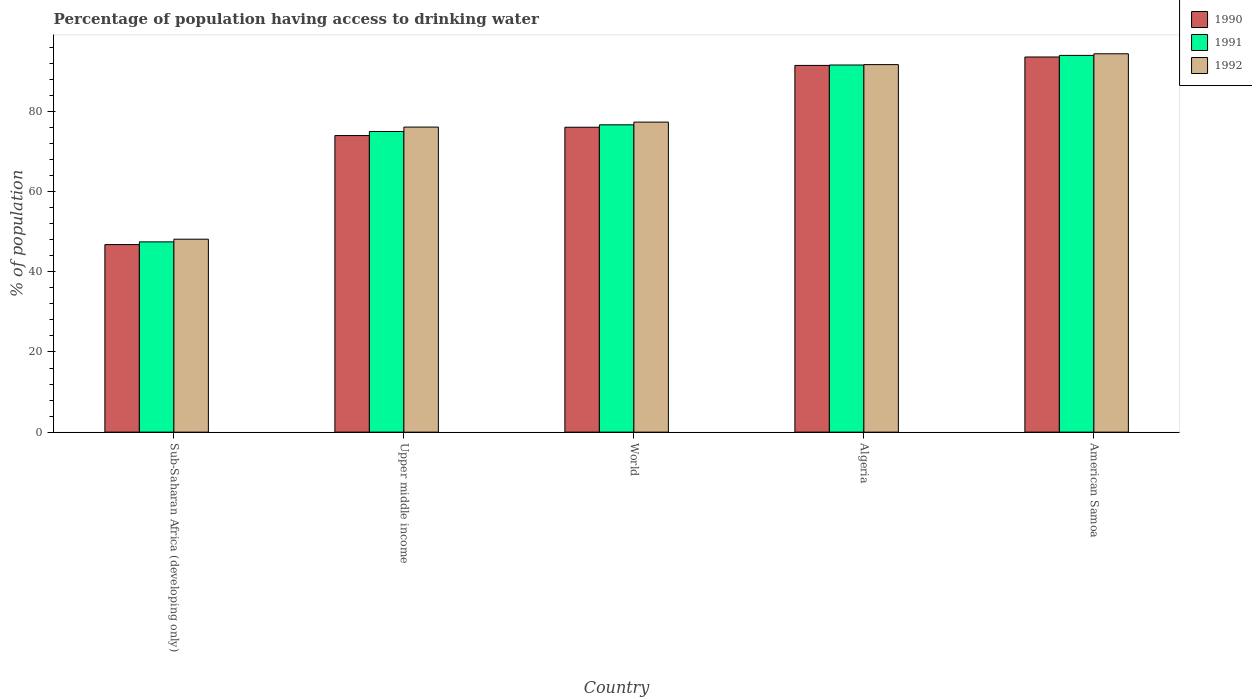Are the number of bars per tick equal to the number of legend labels?
Offer a very short reply. Yes. Are the number of bars on each tick of the X-axis equal?
Give a very brief answer. Yes. What is the label of the 5th group of bars from the left?
Your response must be concise. American Samoa. What is the percentage of population having access to drinking water in 1991 in Algeria?
Offer a terse response. 91.6. Across all countries, what is the maximum percentage of population having access to drinking water in 1991?
Give a very brief answer. 94. Across all countries, what is the minimum percentage of population having access to drinking water in 1990?
Offer a terse response. 46.8. In which country was the percentage of population having access to drinking water in 1990 maximum?
Your answer should be compact. American Samoa. In which country was the percentage of population having access to drinking water in 1991 minimum?
Give a very brief answer. Sub-Saharan Africa (developing only). What is the total percentage of population having access to drinking water in 1991 in the graph?
Your response must be concise. 384.78. What is the difference between the percentage of population having access to drinking water in 1990 in Algeria and that in Upper middle income?
Provide a succinct answer. 17.5. What is the difference between the percentage of population having access to drinking water in 1990 in World and the percentage of population having access to drinking water in 1992 in Upper middle income?
Your answer should be very brief. -0.04. What is the average percentage of population having access to drinking water in 1991 per country?
Your response must be concise. 76.96. What is the difference between the percentage of population having access to drinking water of/in 1991 and percentage of population having access to drinking water of/in 1992 in Upper middle income?
Your answer should be compact. -1.09. In how many countries, is the percentage of population having access to drinking water in 1992 greater than 8 %?
Provide a succinct answer. 5. What is the ratio of the percentage of population having access to drinking water in 1991 in Sub-Saharan Africa (developing only) to that in Upper middle income?
Provide a short and direct response. 0.63. Is the percentage of population having access to drinking water in 1992 in Upper middle income less than that in World?
Your answer should be compact. Yes. What is the difference between the highest and the second highest percentage of population having access to drinking water in 1992?
Keep it short and to the point. 14.35. What is the difference between the highest and the lowest percentage of population having access to drinking water in 1992?
Keep it short and to the point. 46.26. How many bars are there?
Give a very brief answer. 15. Are all the bars in the graph horizontal?
Provide a succinct answer. No. How many countries are there in the graph?
Ensure brevity in your answer.  5. Where does the legend appear in the graph?
Provide a short and direct response. Top right. How many legend labels are there?
Provide a succinct answer. 3. What is the title of the graph?
Your response must be concise. Percentage of population having access to drinking water. What is the label or title of the Y-axis?
Offer a very short reply. % of population. What is the % of population in 1990 in Sub-Saharan Africa (developing only)?
Your response must be concise. 46.8. What is the % of population of 1991 in Sub-Saharan Africa (developing only)?
Your response must be concise. 47.48. What is the % of population in 1992 in Sub-Saharan Africa (developing only)?
Provide a short and direct response. 48.14. What is the % of population in 1990 in Upper middle income?
Give a very brief answer. 74. What is the % of population of 1991 in Upper middle income?
Your response must be concise. 75.02. What is the % of population in 1992 in Upper middle income?
Offer a very short reply. 76.11. What is the % of population in 1990 in World?
Provide a succinct answer. 76.08. What is the % of population in 1991 in World?
Offer a very short reply. 76.68. What is the % of population in 1992 in World?
Provide a succinct answer. 77.35. What is the % of population of 1990 in Algeria?
Your response must be concise. 91.5. What is the % of population of 1991 in Algeria?
Your response must be concise. 91.6. What is the % of population of 1992 in Algeria?
Provide a succinct answer. 91.7. What is the % of population of 1990 in American Samoa?
Keep it short and to the point. 93.6. What is the % of population in 1991 in American Samoa?
Keep it short and to the point. 94. What is the % of population of 1992 in American Samoa?
Your answer should be very brief. 94.4. Across all countries, what is the maximum % of population of 1990?
Offer a very short reply. 93.6. Across all countries, what is the maximum % of population in 1991?
Ensure brevity in your answer.  94. Across all countries, what is the maximum % of population in 1992?
Offer a terse response. 94.4. Across all countries, what is the minimum % of population of 1990?
Provide a succinct answer. 46.8. Across all countries, what is the minimum % of population of 1991?
Give a very brief answer. 47.48. Across all countries, what is the minimum % of population in 1992?
Provide a succinct answer. 48.14. What is the total % of population in 1990 in the graph?
Provide a succinct answer. 381.97. What is the total % of population of 1991 in the graph?
Keep it short and to the point. 384.78. What is the total % of population in 1992 in the graph?
Give a very brief answer. 387.7. What is the difference between the % of population of 1990 in Sub-Saharan Africa (developing only) and that in Upper middle income?
Offer a terse response. -27.2. What is the difference between the % of population in 1991 in Sub-Saharan Africa (developing only) and that in Upper middle income?
Your response must be concise. -27.54. What is the difference between the % of population in 1992 in Sub-Saharan Africa (developing only) and that in Upper middle income?
Offer a very short reply. -27.97. What is the difference between the % of population in 1990 in Sub-Saharan Africa (developing only) and that in World?
Provide a short and direct response. -29.28. What is the difference between the % of population in 1991 in Sub-Saharan Africa (developing only) and that in World?
Provide a succinct answer. -29.2. What is the difference between the % of population of 1992 in Sub-Saharan Africa (developing only) and that in World?
Provide a succinct answer. -29.21. What is the difference between the % of population in 1990 in Sub-Saharan Africa (developing only) and that in Algeria?
Provide a succinct answer. -44.7. What is the difference between the % of population of 1991 in Sub-Saharan Africa (developing only) and that in Algeria?
Ensure brevity in your answer.  -44.12. What is the difference between the % of population of 1992 in Sub-Saharan Africa (developing only) and that in Algeria?
Provide a succinct answer. -43.56. What is the difference between the % of population in 1990 in Sub-Saharan Africa (developing only) and that in American Samoa?
Your answer should be compact. -46.8. What is the difference between the % of population of 1991 in Sub-Saharan Africa (developing only) and that in American Samoa?
Make the answer very short. -46.52. What is the difference between the % of population of 1992 in Sub-Saharan Africa (developing only) and that in American Samoa?
Provide a short and direct response. -46.26. What is the difference between the % of population of 1990 in Upper middle income and that in World?
Your response must be concise. -2.08. What is the difference between the % of population of 1991 in Upper middle income and that in World?
Offer a very short reply. -1.66. What is the difference between the % of population of 1992 in Upper middle income and that in World?
Provide a short and direct response. -1.24. What is the difference between the % of population in 1990 in Upper middle income and that in Algeria?
Provide a short and direct response. -17.5. What is the difference between the % of population in 1991 in Upper middle income and that in Algeria?
Your answer should be very brief. -16.58. What is the difference between the % of population in 1992 in Upper middle income and that in Algeria?
Provide a succinct answer. -15.59. What is the difference between the % of population in 1990 in Upper middle income and that in American Samoa?
Make the answer very short. -19.6. What is the difference between the % of population of 1991 in Upper middle income and that in American Samoa?
Ensure brevity in your answer.  -18.98. What is the difference between the % of population of 1992 in Upper middle income and that in American Samoa?
Ensure brevity in your answer.  -18.29. What is the difference between the % of population in 1990 in World and that in Algeria?
Give a very brief answer. -15.42. What is the difference between the % of population in 1991 in World and that in Algeria?
Your answer should be very brief. -14.92. What is the difference between the % of population in 1992 in World and that in Algeria?
Provide a short and direct response. -14.35. What is the difference between the % of population in 1990 in World and that in American Samoa?
Ensure brevity in your answer.  -17.52. What is the difference between the % of population of 1991 in World and that in American Samoa?
Keep it short and to the point. -17.32. What is the difference between the % of population of 1992 in World and that in American Samoa?
Keep it short and to the point. -17.05. What is the difference between the % of population of 1991 in Algeria and that in American Samoa?
Make the answer very short. -2.4. What is the difference between the % of population in 1990 in Sub-Saharan Africa (developing only) and the % of population in 1991 in Upper middle income?
Keep it short and to the point. -28.22. What is the difference between the % of population of 1990 in Sub-Saharan Africa (developing only) and the % of population of 1992 in Upper middle income?
Give a very brief answer. -29.32. What is the difference between the % of population of 1991 in Sub-Saharan Africa (developing only) and the % of population of 1992 in Upper middle income?
Your answer should be compact. -28.64. What is the difference between the % of population in 1990 in Sub-Saharan Africa (developing only) and the % of population in 1991 in World?
Your answer should be very brief. -29.89. What is the difference between the % of population of 1990 in Sub-Saharan Africa (developing only) and the % of population of 1992 in World?
Give a very brief answer. -30.56. What is the difference between the % of population of 1991 in Sub-Saharan Africa (developing only) and the % of population of 1992 in World?
Your answer should be very brief. -29.87. What is the difference between the % of population in 1990 in Sub-Saharan Africa (developing only) and the % of population in 1991 in Algeria?
Provide a short and direct response. -44.8. What is the difference between the % of population in 1990 in Sub-Saharan Africa (developing only) and the % of population in 1992 in Algeria?
Give a very brief answer. -44.9. What is the difference between the % of population in 1991 in Sub-Saharan Africa (developing only) and the % of population in 1992 in Algeria?
Your response must be concise. -44.22. What is the difference between the % of population of 1990 in Sub-Saharan Africa (developing only) and the % of population of 1991 in American Samoa?
Make the answer very short. -47.2. What is the difference between the % of population of 1990 in Sub-Saharan Africa (developing only) and the % of population of 1992 in American Samoa?
Your answer should be compact. -47.6. What is the difference between the % of population in 1991 in Sub-Saharan Africa (developing only) and the % of population in 1992 in American Samoa?
Ensure brevity in your answer.  -46.92. What is the difference between the % of population in 1990 in Upper middle income and the % of population in 1991 in World?
Keep it short and to the point. -2.68. What is the difference between the % of population of 1990 in Upper middle income and the % of population of 1992 in World?
Give a very brief answer. -3.35. What is the difference between the % of population of 1991 in Upper middle income and the % of population of 1992 in World?
Offer a terse response. -2.33. What is the difference between the % of population of 1990 in Upper middle income and the % of population of 1991 in Algeria?
Ensure brevity in your answer.  -17.6. What is the difference between the % of population of 1990 in Upper middle income and the % of population of 1992 in Algeria?
Offer a very short reply. -17.7. What is the difference between the % of population in 1991 in Upper middle income and the % of population in 1992 in Algeria?
Ensure brevity in your answer.  -16.68. What is the difference between the % of population of 1990 in Upper middle income and the % of population of 1991 in American Samoa?
Keep it short and to the point. -20. What is the difference between the % of population of 1990 in Upper middle income and the % of population of 1992 in American Samoa?
Your response must be concise. -20.4. What is the difference between the % of population in 1991 in Upper middle income and the % of population in 1992 in American Samoa?
Your response must be concise. -19.38. What is the difference between the % of population of 1990 in World and the % of population of 1991 in Algeria?
Give a very brief answer. -15.52. What is the difference between the % of population of 1990 in World and the % of population of 1992 in Algeria?
Your answer should be very brief. -15.62. What is the difference between the % of population of 1991 in World and the % of population of 1992 in Algeria?
Provide a short and direct response. -15.02. What is the difference between the % of population in 1990 in World and the % of population in 1991 in American Samoa?
Your answer should be very brief. -17.92. What is the difference between the % of population in 1990 in World and the % of population in 1992 in American Samoa?
Provide a short and direct response. -18.32. What is the difference between the % of population of 1991 in World and the % of population of 1992 in American Samoa?
Your response must be concise. -17.72. What is the difference between the % of population of 1990 in Algeria and the % of population of 1991 in American Samoa?
Offer a very short reply. -2.5. What is the difference between the % of population in 1990 in Algeria and the % of population in 1992 in American Samoa?
Provide a short and direct response. -2.9. What is the average % of population of 1990 per country?
Provide a succinct answer. 76.39. What is the average % of population of 1991 per country?
Ensure brevity in your answer.  76.96. What is the average % of population of 1992 per country?
Ensure brevity in your answer.  77.54. What is the difference between the % of population in 1990 and % of population in 1991 in Sub-Saharan Africa (developing only)?
Ensure brevity in your answer.  -0.68. What is the difference between the % of population of 1990 and % of population of 1992 in Sub-Saharan Africa (developing only)?
Your answer should be very brief. -1.34. What is the difference between the % of population in 1991 and % of population in 1992 in Sub-Saharan Africa (developing only)?
Offer a terse response. -0.66. What is the difference between the % of population of 1990 and % of population of 1991 in Upper middle income?
Give a very brief answer. -1.02. What is the difference between the % of population of 1990 and % of population of 1992 in Upper middle income?
Keep it short and to the point. -2.12. What is the difference between the % of population of 1991 and % of population of 1992 in Upper middle income?
Ensure brevity in your answer.  -1.09. What is the difference between the % of population of 1990 and % of population of 1991 in World?
Offer a very short reply. -0.6. What is the difference between the % of population in 1990 and % of population in 1992 in World?
Provide a succinct answer. -1.28. What is the difference between the % of population of 1991 and % of population of 1992 in World?
Give a very brief answer. -0.67. What is the difference between the % of population in 1990 and % of population in 1991 in Algeria?
Make the answer very short. -0.1. What is the difference between the % of population of 1990 and % of population of 1992 in Algeria?
Offer a very short reply. -0.2. What is the ratio of the % of population in 1990 in Sub-Saharan Africa (developing only) to that in Upper middle income?
Your answer should be compact. 0.63. What is the ratio of the % of population of 1991 in Sub-Saharan Africa (developing only) to that in Upper middle income?
Provide a succinct answer. 0.63. What is the ratio of the % of population in 1992 in Sub-Saharan Africa (developing only) to that in Upper middle income?
Offer a terse response. 0.63. What is the ratio of the % of population of 1990 in Sub-Saharan Africa (developing only) to that in World?
Provide a short and direct response. 0.62. What is the ratio of the % of population of 1991 in Sub-Saharan Africa (developing only) to that in World?
Make the answer very short. 0.62. What is the ratio of the % of population in 1992 in Sub-Saharan Africa (developing only) to that in World?
Provide a succinct answer. 0.62. What is the ratio of the % of population of 1990 in Sub-Saharan Africa (developing only) to that in Algeria?
Ensure brevity in your answer.  0.51. What is the ratio of the % of population in 1991 in Sub-Saharan Africa (developing only) to that in Algeria?
Make the answer very short. 0.52. What is the ratio of the % of population of 1992 in Sub-Saharan Africa (developing only) to that in Algeria?
Offer a very short reply. 0.53. What is the ratio of the % of population in 1991 in Sub-Saharan Africa (developing only) to that in American Samoa?
Your answer should be compact. 0.51. What is the ratio of the % of population in 1992 in Sub-Saharan Africa (developing only) to that in American Samoa?
Offer a very short reply. 0.51. What is the ratio of the % of population of 1990 in Upper middle income to that in World?
Offer a terse response. 0.97. What is the ratio of the % of population of 1991 in Upper middle income to that in World?
Ensure brevity in your answer.  0.98. What is the ratio of the % of population of 1992 in Upper middle income to that in World?
Provide a succinct answer. 0.98. What is the ratio of the % of population of 1990 in Upper middle income to that in Algeria?
Give a very brief answer. 0.81. What is the ratio of the % of population of 1991 in Upper middle income to that in Algeria?
Make the answer very short. 0.82. What is the ratio of the % of population of 1992 in Upper middle income to that in Algeria?
Your answer should be very brief. 0.83. What is the ratio of the % of population of 1990 in Upper middle income to that in American Samoa?
Your answer should be very brief. 0.79. What is the ratio of the % of population in 1991 in Upper middle income to that in American Samoa?
Provide a succinct answer. 0.8. What is the ratio of the % of population of 1992 in Upper middle income to that in American Samoa?
Provide a short and direct response. 0.81. What is the ratio of the % of population in 1990 in World to that in Algeria?
Make the answer very short. 0.83. What is the ratio of the % of population in 1991 in World to that in Algeria?
Offer a very short reply. 0.84. What is the ratio of the % of population of 1992 in World to that in Algeria?
Offer a very short reply. 0.84. What is the ratio of the % of population in 1990 in World to that in American Samoa?
Offer a terse response. 0.81. What is the ratio of the % of population of 1991 in World to that in American Samoa?
Keep it short and to the point. 0.82. What is the ratio of the % of population in 1992 in World to that in American Samoa?
Provide a short and direct response. 0.82. What is the ratio of the % of population in 1990 in Algeria to that in American Samoa?
Give a very brief answer. 0.98. What is the ratio of the % of population of 1991 in Algeria to that in American Samoa?
Give a very brief answer. 0.97. What is the ratio of the % of population in 1992 in Algeria to that in American Samoa?
Make the answer very short. 0.97. What is the difference between the highest and the second highest % of population of 1991?
Keep it short and to the point. 2.4. What is the difference between the highest and the lowest % of population of 1990?
Offer a very short reply. 46.8. What is the difference between the highest and the lowest % of population of 1991?
Keep it short and to the point. 46.52. What is the difference between the highest and the lowest % of population in 1992?
Your response must be concise. 46.26. 